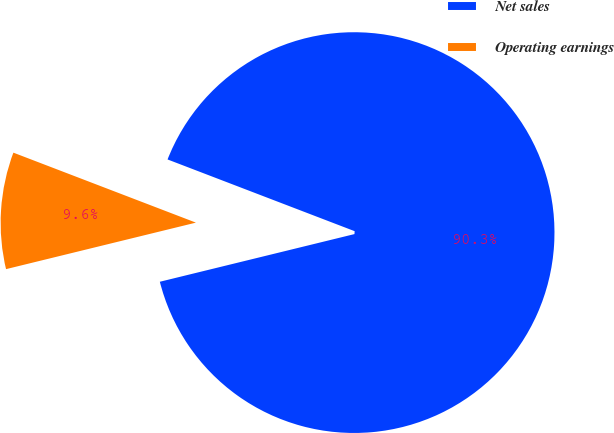Convert chart. <chart><loc_0><loc_0><loc_500><loc_500><pie_chart><fcel>Net sales<fcel>Operating earnings<nl><fcel>90.35%<fcel>9.65%<nl></chart> 